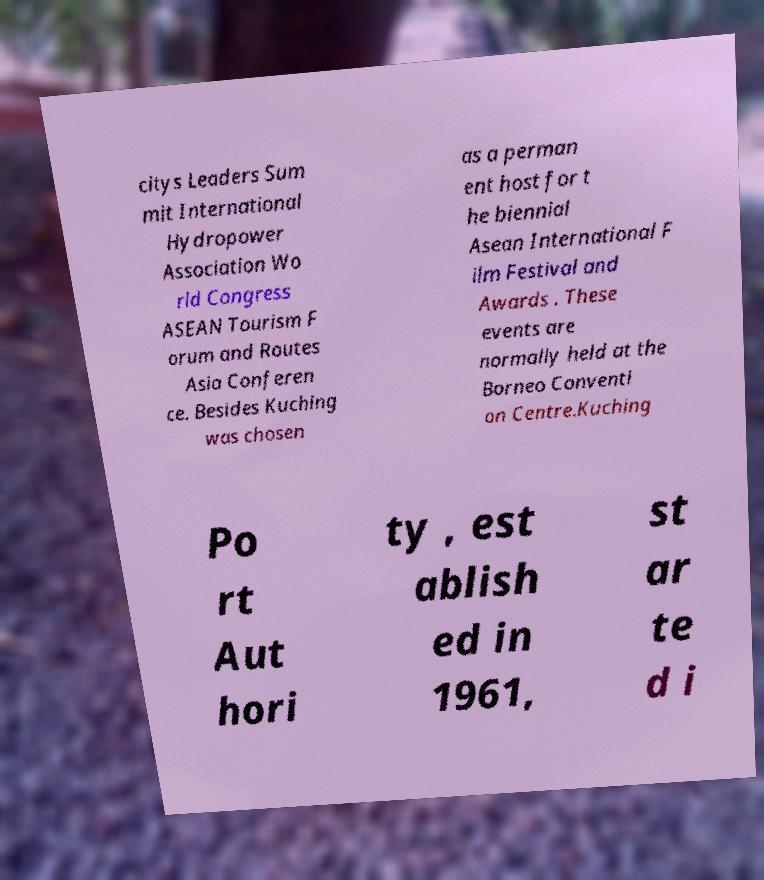Could you extract and type out the text from this image? citys Leaders Sum mit International Hydropower Association Wo rld Congress ASEAN Tourism F orum and Routes Asia Conferen ce. Besides Kuching was chosen as a perman ent host for t he biennial Asean International F ilm Festival and Awards . These events are normally held at the Borneo Conventi on Centre.Kuching Po rt Aut hori ty , est ablish ed in 1961, st ar te d i 